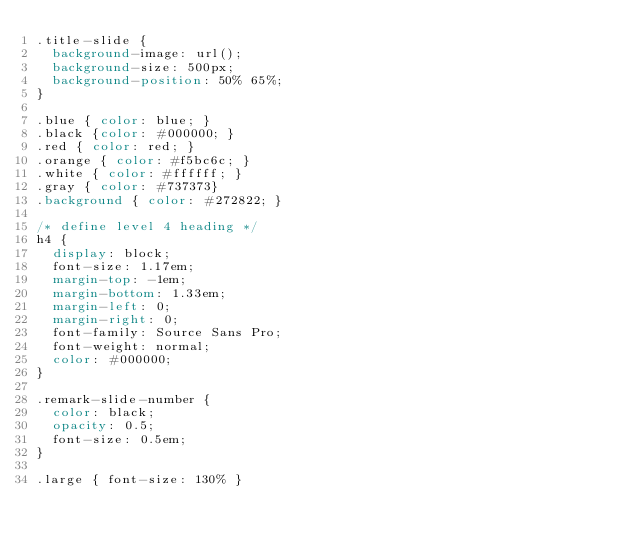Convert code to text. <code><loc_0><loc_0><loc_500><loc_500><_CSS_>.title-slide {
  background-image: url();
  background-size: 500px;
  background-position: 50% 65%;
}

.blue { color: blue; }
.black {color: #000000; }
.red { color: red; }
.orange { color: #f5bc6c; }
.white { color: #ffffff; }
.gray { color: #737373}
.background { color: #272822; }

/* define level 4 heading */
h4 {
  display: block;
  font-size: 1.17em;
  margin-top: -1em;
  margin-bottom: 1.33em;
  margin-left: 0;
  margin-right: 0;
  font-family: Source Sans Pro;
  font-weight: normal;
  color: #000000;
}

.remark-slide-number {
  color: black;
  opacity: 0.5;
  font-size: 0.5em;
}

.large { font-size: 130% }</code> 